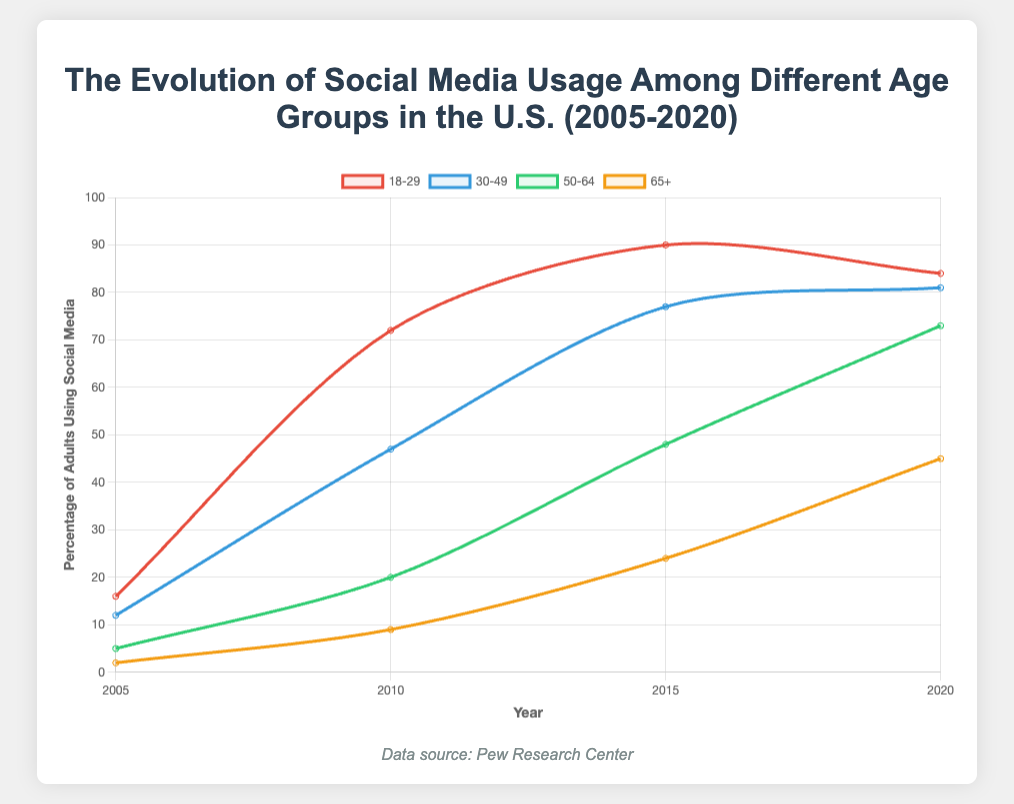What age group showed the largest increase in social media usage from 2005 to 2020? To find the largest increase, subtract the initial value in 2005 from the final value in 2020 for each age group, then compare these differences. For ages 18-29, the increase is 84 - 16 = 68. For ages 30-49, it's 81 - 12 = 69. For ages 50-64, it's 73 - 5 = 68. For ages 65+, it's 45 - 2 = 43. The largest increase is for the age group 30-49.
Answer: Ages 30-49 Which age group had the lowest percentage of social media usage in 2010? Compare the 2010 values across all age groups. Ages 18-29 had 72%, ages 30-49 had 47%, ages 50-64 had 20%, and ages 65+ had 9%. Therefore, the lowest percentage of social media usage in 2010 was in the 65+ age group.
Answer: Ages 65+ How did the percentage of social media usage for the 50-64 age group change from 2010 to 2015? Find the difference between the 2015 and 2010 values for the 50-64 age group. Subtract the 2010 value from the 2015 value: 48 - 20 = 28. Thus, social media usage increased by 28 percentage points.
Answer: Increased by 28 percentage points What is the difference in social media usage between the 18-29 and 65+ age groups in 2020? Subtract the 2020 value of the 65+ age group from the 2020 value of the 18-29 age group: 84 - 45 = 39. The difference in usage is 39 percentage points.
Answer: 39 percentage points Which age group experienced the smallest decline from its peak usage and what was that decline? Look at the peak value for each age group and compare it with the 2020 value. For ages 18-29, the peak was 90 in 2015 and declined to 84 in 2020, a decline of 6. Ages 30-49 had a peak of 81 in 2020 with no decline. Ages 50-64 and 65+ also peaked in 2020. Therefore, ages 30-49 experienced no decline from its peak usage.
Answer: Ages 30-49, no decline How does the trend of social media usage of the 65+ age group from 2005 to 2020 visually compare to the 18-29 age group? Visually, the 65+ age group shows a sharp, continuous increase over the years with steady growth, while the 18-29 age group shows a rapid increase initially and a slight decline from its peak in 2015. The biggest visual difference is that the younger age group’s trend line flattens and declines slightly towards the end, whereas the older group's line continuously rises.
Answer: 65+ shows continuous increase; 18-29 flattens and slightly declines By looking at the colors of the lines, which color corresponds to the 50-64 age group on the plot? The 50-64 age group is represented by the green line on the plot, as indicated by the visual legend and the chart.
Answer: Green Between which years did the ages 30-49 group see the most significant increase in social media usage? By visually assessing the steepness of the line for ages 30-49, the most significant increase occurs between 2010 (47%) and 2015 (77%), an increase of 30 percentage points.
Answer: Between 2010 and 2015 If you average the social media usage of the 30-49 age group across all years, what is the result? Add the usage values for ages 30-49 (12 + 47 + 77 + 81) and divide by the number of years (4). (12 + 47 + 77 + 81) / 4 = 54.25. Therefore, the average is approximately 54.25%.
Answer: 54.25% 